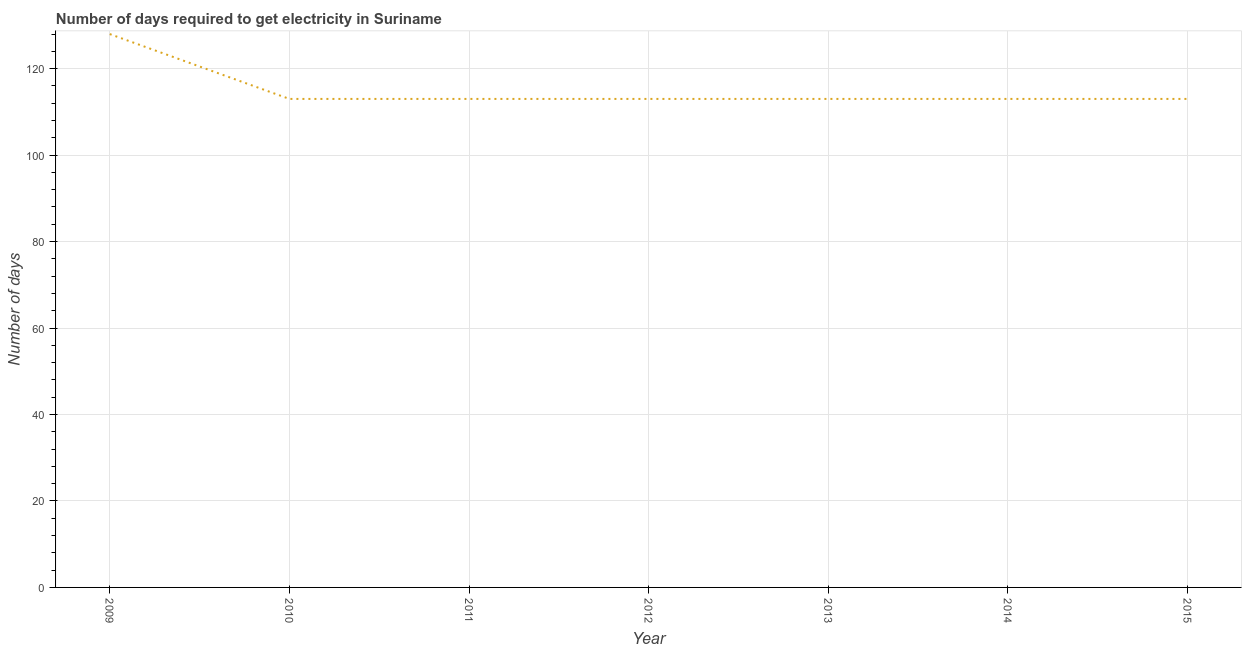What is the time to get electricity in 2013?
Provide a short and direct response. 113. Across all years, what is the maximum time to get electricity?
Your answer should be very brief. 128. Across all years, what is the minimum time to get electricity?
Give a very brief answer. 113. In which year was the time to get electricity minimum?
Keep it short and to the point. 2010. What is the sum of the time to get electricity?
Make the answer very short. 806. What is the difference between the time to get electricity in 2009 and 2014?
Offer a terse response. 15. What is the average time to get electricity per year?
Make the answer very short. 115.14. What is the median time to get electricity?
Ensure brevity in your answer.  113. In how many years, is the time to get electricity greater than 40 ?
Keep it short and to the point. 7. Is the difference between the time to get electricity in 2013 and 2014 greater than the difference between any two years?
Your answer should be very brief. No. What is the difference between the highest and the second highest time to get electricity?
Offer a very short reply. 15. What is the difference between the highest and the lowest time to get electricity?
Provide a short and direct response. 15. Does the time to get electricity monotonically increase over the years?
Offer a terse response. No. How many years are there in the graph?
Keep it short and to the point. 7. Are the values on the major ticks of Y-axis written in scientific E-notation?
Your response must be concise. No. What is the title of the graph?
Make the answer very short. Number of days required to get electricity in Suriname. What is the label or title of the X-axis?
Ensure brevity in your answer.  Year. What is the label or title of the Y-axis?
Keep it short and to the point. Number of days. What is the Number of days of 2009?
Give a very brief answer. 128. What is the Number of days in 2010?
Offer a terse response. 113. What is the Number of days in 2011?
Your response must be concise. 113. What is the Number of days of 2012?
Provide a short and direct response. 113. What is the Number of days of 2013?
Give a very brief answer. 113. What is the Number of days in 2014?
Provide a succinct answer. 113. What is the Number of days of 2015?
Your answer should be compact. 113. What is the difference between the Number of days in 2009 and 2012?
Your response must be concise. 15. What is the difference between the Number of days in 2009 and 2013?
Give a very brief answer. 15. What is the difference between the Number of days in 2009 and 2014?
Provide a short and direct response. 15. What is the difference between the Number of days in 2010 and 2011?
Your answer should be compact. 0. What is the difference between the Number of days in 2010 and 2015?
Offer a very short reply. 0. What is the difference between the Number of days in 2011 and 2014?
Provide a succinct answer. 0. What is the difference between the Number of days in 2011 and 2015?
Your answer should be very brief. 0. What is the difference between the Number of days in 2012 and 2013?
Provide a succinct answer. 0. What is the difference between the Number of days in 2012 and 2014?
Your answer should be very brief. 0. What is the difference between the Number of days in 2012 and 2015?
Provide a short and direct response. 0. What is the difference between the Number of days in 2013 and 2014?
Give a very brief answer. 0. What is the difference between the Number of days in 2013 and 2015?
Make the answer very short. 0. What is the ratio of the Number of days in 2009 to that in 2010?
Your answer should be very brief. 1.13. What is the ratio of the Number of days in 2009 to that in 2011?
Your response must be concise. 1.13. What is the ratio of the Number of days in 2009 to that in 2012?
Keep it short and to the point. 1.13. What is the ratio of the Number of days in 2009 to that in 2013?
Ensure brevity in your answer.  1.13. What is the ratio of the Number of days in 2009 to that in 2014?
Ensure brevity in your answer.  1.13. What is the ratio of the Number of days in 2009 to that in 2015?
Provide a succinct answer. 1.13. What is the ratio of the Number of days in 2010 to that in 2011?
Your response must be concise. 1. What is the ratio of the Number of days in 2010 to that in 2013?
Provide a succinct answer. 1. What is the ratio of the Number of days in 2010 to that in 2014?
Your answer should be very brief. 1. What is the ratio of the Number of days in 2010 to that in 2015?
Make the answer very short. 1. What is the ratio of the Number of days in 2011 to that in 2013?
Make the answer very short. 1. What is the ratio of the Number of days in 2011 to that in 2014?
Provide a short and direct response. 1. What is the ratio of the Number of days in 2011 to that in 2015?
Your answer should be compact. 1. What is the ratio of the Number of days in 2012 to that in 2013?
Provide a succinct answer. 1. What is the ratio of the Number of days in 2012 to that in 2014?
Ensure brevity in your answer.  1. What is the ratio of the Number of days in 2014 to that in 2015?
Provide a succinct answer. 1. 